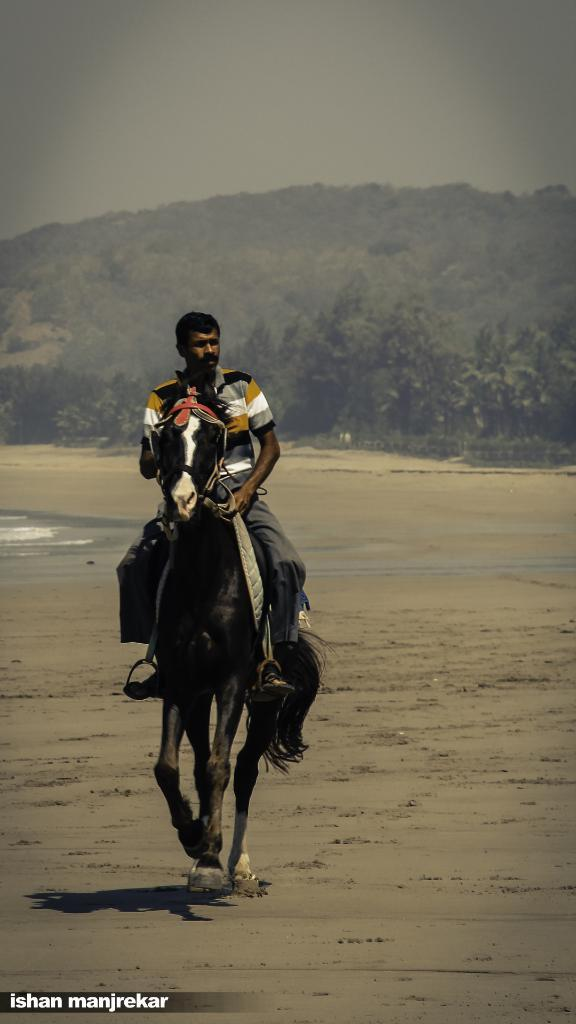Who is the main subject in the image? There is a man in the image. What is the man doing in the image? The man is sitting on a horse. What can be seen in the background of the image? There are trees in the background of the image. What is visible at the top of the image? The sky is visible at the top of the image. What day of the week is it in the image? The day of the week is not mentioned or visible in the image. 